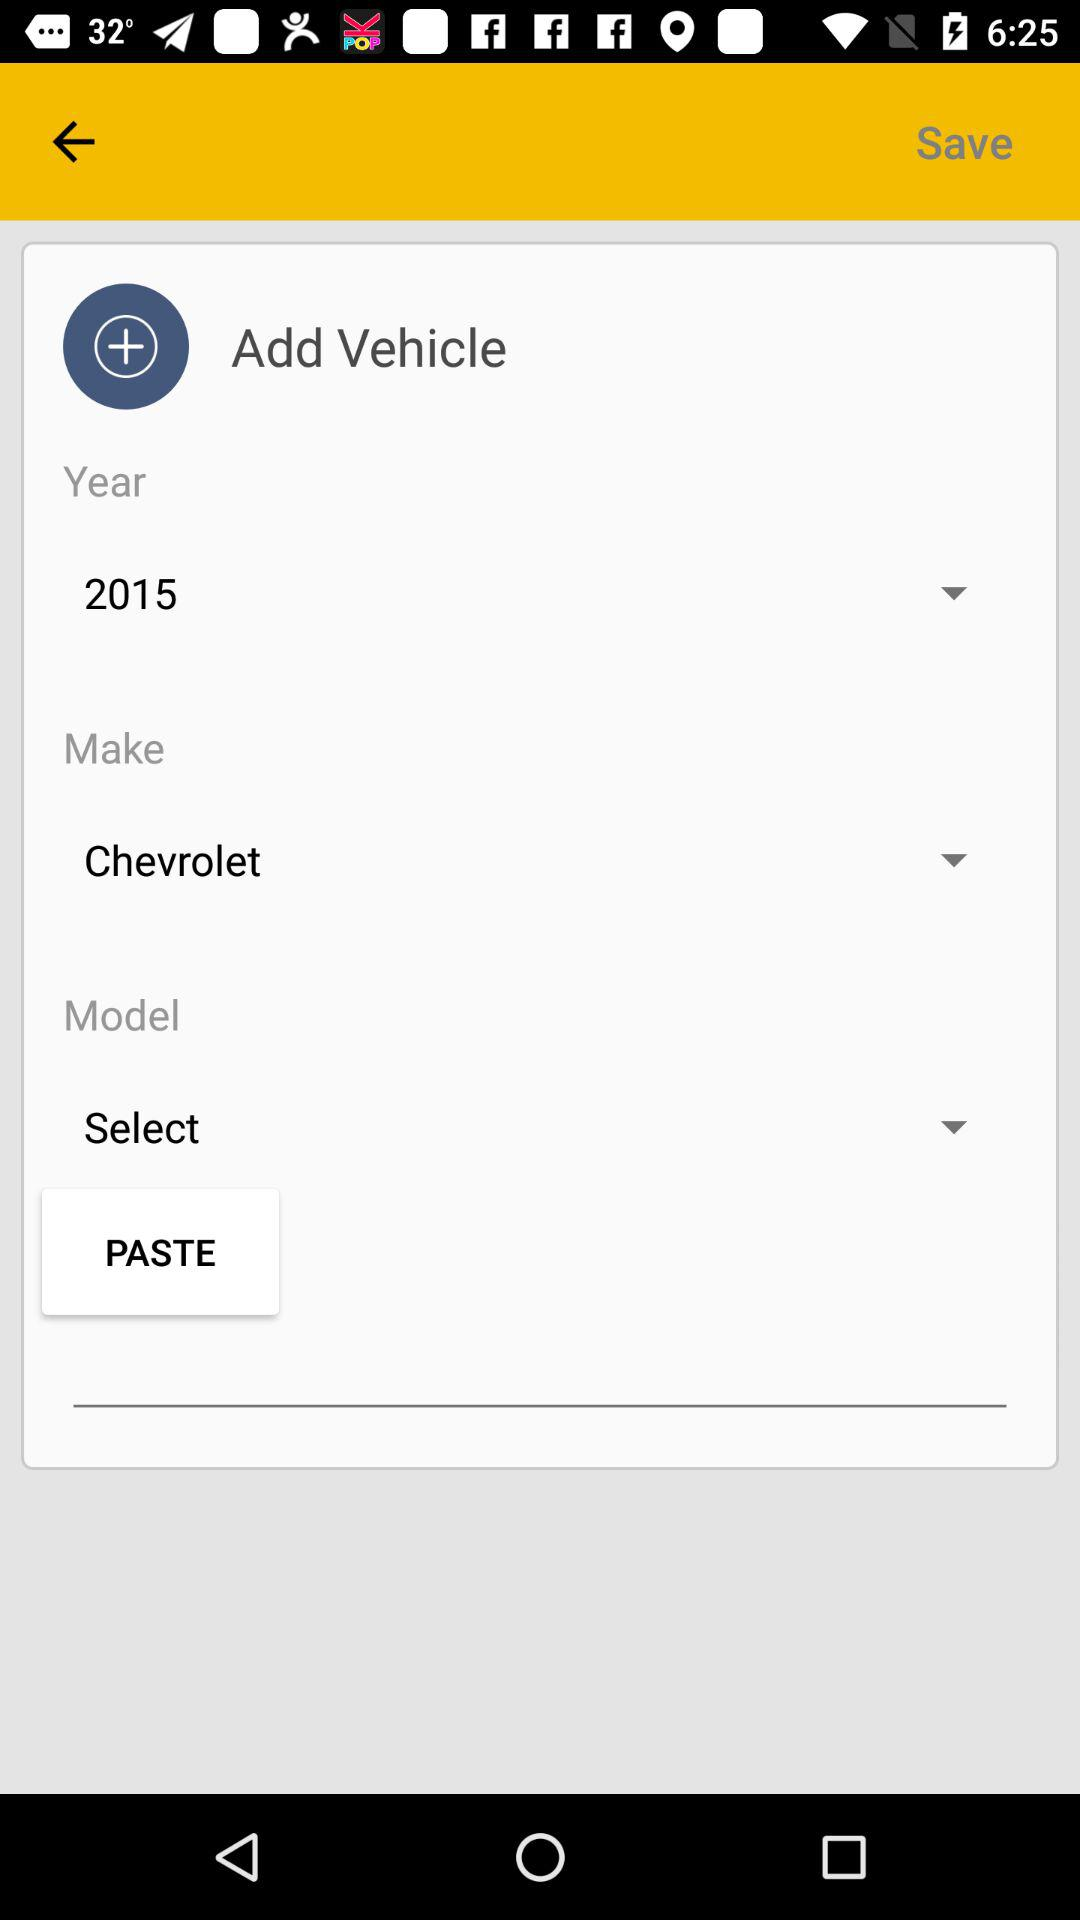What is the name of the manufacturer of the vehicle? The name of the manufacturer of the vehicle is "Chevrolet". 